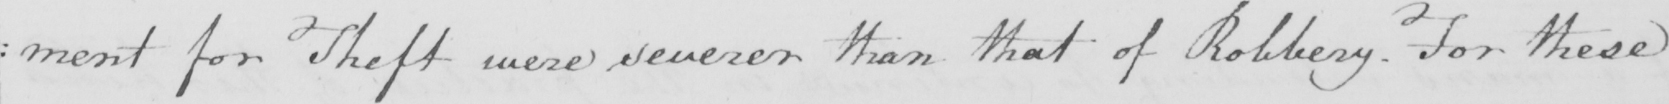Please transcribe the handwritten text in this image. : ment for Theft were severer than that of Robbery . For these 